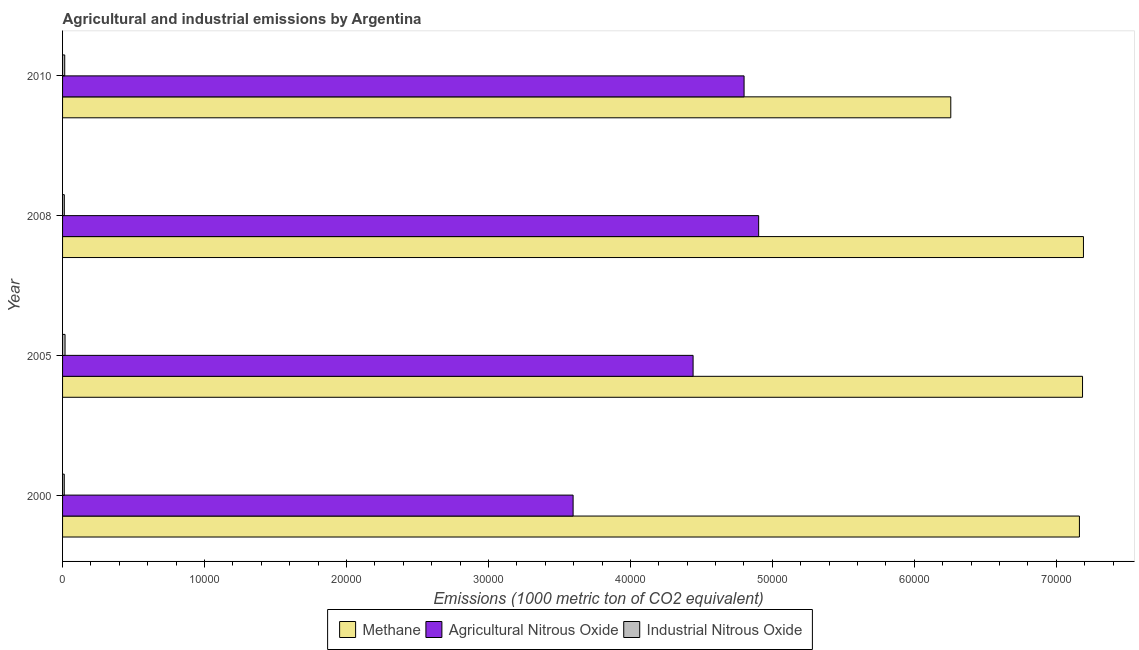How many different coloured bars are there?
Keep it short and to the point. 3. How many groups of bars are there?
Your answer should be compact. 4. Are the number of bars on each tick of the Y-axis equal?
Provide a succinct answer. Yes. How many bars are there on the 1st tick from the bottom?
Give a very brief answer. 3. What is the label of the 2nd group of bars from the top?
Provide a short and direct response. 2008. In how many cases, is the number of bars for a given year not equal to the number of legend labels?
Your response must be concise. 0. What is the amount of agricultural nitrous oxide emissions in 2005?
Make the answer very short. 4.44e+04. Across all years, what is the maximum amount of methane emissions?
Provide a succinct answer. 7.19e+04. Across all years, what is the minimum amount of industrial nitrous oxide emissions?
Your response must be concise. 120. In which year was the amount of agricultural nitrous oxide emissions maximum?
Offer a very short reply. 2008. In which year was the amount of industrial nitrous oxide emissions minimum?
Your answer should be compact. 2000. What is the total amount of industrial nitrous oxide emissions in the graph?
Ensure brevity in your answer.  569.2. What is the difference between the amount of agricultural nitrous oxide emissions in 2000 and that in 2005?
Keep it short and to the point. -8453.1. What is the difference between the amount of agricultural nitrous oxide emissions in 2000 and the amount of industrial nitrous oxide emissions in 2005?
Keep it short and to the point. 3.58e+04. What is the average amount of industrial nitrous oxide emissions per year?
Your response must be concise. 142.3. In the year 2005, what is the difference between the amount of methane emissions and amount of industrial nitrous oxide emissions?
Offer a very short reply. 7.17e+04. In how many years, is the amount of industrial nitrous oxide emissions greater than 20000 metric ton?
Offer a terse response. 0. What is the ratio of the amount of industrial nitrous oxide emissions in 2000 to that in 2005?
Your answer should be very brief. 0.69. Is the amount of agricultural nitrous oxide emissions in 2008 less than that in 2010?
Your response must be concise. No. What is the difference between the highest and the second highest amount of methane emissions?
Your answer should be compact. 64.1. What is the difference between the highest and the lowest amount of agricultural nitrous oxide emissions?
Your response must be concise. 1.31e+04. Is the sum of the amount of agricultural nitrous oxide emissions in 2005 and 2010 greater than the maximum amount of industrial nitrous oxide emissions across all years?
Offer a very short reply. Yes. What does the 3rd bar from the top in 2005 represents?
Make the answer very short. Methane. What does the 2nd bar from the bottom in 2000 represents?
Your answer should be compact. Agricultural Nitrous Oxide. Is it the case that in every year, the sum of the amount of methane emissions and amount of agricultural nitrous oxide emissions is greater than the amount of industrial nitrous oxide emissions?
Offer a terse response. Yes. How many bars are there?
Make the answer very short. 12. Are all the bars in the graph horizontal?
Provide a short and direct response. Yes. What is the difference between two consecutive major ticks on the X-axis?
Keep it short and to the point. 10000. Does the graph contain any zero values?
Keep it short and to the point. No. How are the legend labels stacked?
Your answer should be very brief. Horizontal. What is the title of the graph?
Make the answer very short. Agricultural and industrial emissions by Argentina. What is the label or title of the X-axis?
Make the answer very short. Emissions (1000 metric ton of CO2 equivalent). What is the label or title of the Y-axis?
Provide a succinct answer. Year. What is the Emissions (1000 metric ton of CO2 equivalent) of Methane in 2000?
Give a very brief answer. 7.16e+04. What is the Emissions (1000 metric ton of CO2 equivalent) of Agricultural Nitrous Oxide in 2000?
Your answer should be very brief. 3.60e+04. What is the Emissions (1000 metric ton of CO2 equivalent) of Industrial Nitrous Oxide in 2000?
Provide a short and direct response. 120. What is the Emissions (1000 metric ton of CO2 equivalent) in Methane in 2005?
Provide a succinct answer. 7.19e+04. What is the Emissions (1000 metric ton of CO2 equivalent) in Agricultural Nitrous Oxide in 2005?
Ensure brevity in your answer.  4.44e+04. What is the Emissions (1000 metric ton of CO2 equivalent) of Industrial Nitrous Oxide in 2005?
Make the answer very short. 174.4. What is the Emissions (1000 metric ton of CO2 equivalent) of Methane in 2008?
Provide a succinct answer. 7.19e+04. What is the Emissions (1000 metric ton of CO2 equivalent) of Agricultural Nitrous Oxide in 2008?
Provide a short and direct response. 4.90e+04. What is the Emissions (1000 metric ton of CO2 equivalent) in Industrial Nitrous Oxide in 2008?
Offer a terse response. 123. What is the Emissions (1000 metric ton of CO2 equivalent) in Methane in 2010?
Offer a terse response. 6.26e+04. What is the Emissions (1000 metric ton of CO2 equivalent) in Agricultural Nitrous Oxide in 2010?
Provide a short and direct response. 4.80e+04. What is the Emissions (1000 metric ton of CO2 equivalent) of Industrial Nitrous Oxide in 2010?
Offer a very short reply. 151.8. Across all years, what is the maximum Emissions (1000 metric ton of CO2 equivalent) of Methane?
Offer a terse response. 7.19e+04. Across all years, what is the maximum Emissions (1000 metric ton of CO2 equivalent) in Agricultural Nitrous Oxide?
Provide a succinct answer. 4.90e+04. Across all years, what is the maximum Emissions (1000 metric ton of CO2 equivalent) of Industrial Nitrous Oxide?
Your answer should be very brief. 174.4. Across all years, what is the minimum Emissions (1000 metric ton of CO2 equivalent) in Methane?
Offer a very short reply. 6.26e+04. Across all years, what is the minimum Emissions (1000 metric ton of CO2 equivalent) of Agricultural Nitrous Oxide?
Offer a very short reply. 3.60e+04. Across all years, what is the minimum Emissions (1000 metric ton of CO2 equivalent) in Industrial Nitrous Oxide?
Make the answer very short. 120. What is the total Emissions (1000 metric ton of CO2 equivalent) in Methane in the graph?
Your response must be concise. 2.78e+05. What is the total Emissions (1000 metric ton of CO2 equivalent) of Agricultural Nitrous Oxide in the graph?
Your answer should be compact. 1.77e+05. What is the total Emissions (1000 metric ton of CO2 equivalent) in Industrial Nitrous Oxide in the graph?
Make the answer very short. 569.2. What is the difference between the Emissions (1000 metric ton of CO2 equivalent) of Methane in 2000 and that in 2005?
Offer a very short reply. -219. What is the difference between the Emissions (1000 metric ton of CO2 equivalent) in Agricultural Nitrous Oxide in 2000 and that in 2005?
Your response must be concise. -8453.1. What is the difference between the Emissions (1000 metric ton of CO2 equivalent) in Industrial Nitrous Oxide in 2000 and that in 2005?
Keep it short and to the point. -54.4. What is the difference between the Emissions (1000 metric ton of CO2 equivalent) of Methane in 2000 and that in 2008?
Provide a short and direct response. -283.1. What is the difference between the Emissions (1000 metric ton of CO2 equivalent) of Agricultural Nitrous Oxide in 2000 and that in 2008?
Keep it short and to the point. -1.31e+04. What is the difference between the Emissions (1000 metric ton of CO2 equivalent) of Industrial Nitrous Oxide in 2000 and that in 2008?
Give a very brief answer. -3. What is the difference between the Emissions (1000 metric ton of CO2 equivalent) in Methane in 2000 and that in 2010?
Provide a succinct answer. 9062.7. What is the difference between the Emissions (1000 metric ton of CO2 equivalent) in Agricultural Nitrous Oxide in 2000 and that in 2010?
Ensure brevity in your answer.  -1.20e+04. What is the difference between the Emissions (1000 metric ton of CO2 equivalent) of Industrial Nitrous Oxide in 2000 and that in 2010?
Offer a very short reply. -31.8. What is the difference between the Emissions (1000 metric ton of CO2 equivalent) in Methane in 2005 and that in 2008?
Provide a short and direct response. -64.1. What is the difference between the Emissions (1000 metric ton of CO2 equivalent) in Agricultural Nitrous Oxide in 2005 and that in 2008?
Your answer should be compact. -4617.7. What is the difference between the Emissions (1000 metric ton of CO2 equivalent) of Industrial Nitrous Oxide in 2005 and that in 2008?
Your answer should be very brief. 51.4. What is the difference between the Emissions (1000 metric ton of CO2 equivalent) of Methane in 2005 and that in 2010?
Give a very brief answer. 9281.7. What is the difference between the Emissions (1000 metric ton of CO2 equivalent) of Agricultural Nitrous Oxide in 2005 and that in 2010?
Your answer should be very brief. -3591.7. What is the difference between the Emissions (1000 metric ton of CO2 equivalent) in Industrial Nitrous Oxide in 2005 and that in 2010?
Offer a terse response. 22.6. What is the difference between the Emissions (1000 metric ton of CO2 equivalent) of Methane in 2008 and that in 2010?
Provide a succinct answer. 9345.8. What is the difference between the Emissions (1000 metric ton of CO2 equivalent) of Agricultural Nitrous Oxide in 2008 and that in 2010?
Your answer should be very brief. 1026. What is the difference between the Emissions (1000 metric ton of CO2 equivalent) of Industrial Nitrous Oxide in 2008 and that in 2010?
Keep it short and to the point. -28.8. What is the difference between the Emissions (1000 metric ton of CO2 equivalent) in Methane in 2000 and the Emissions (1000 metric ton of CO2 equivalent) in Agricultural Nitrous Oxide in 2005?
Your answer should be compact. 2.72e+04. What is the difference between the Emissions (1000 metric ton of CO2 equivalent) of Methane in 2000 and the Emissions (1000 metric ton of CO2 equivalent) of Industrial Nitrous Oxide in 2005?
Give a very brief answer. 7.15e+04. What is the difference between the Emissions (1000 metric ton of CO2 equivalent) in Agricultural Nitrous Oxide in 2000 and the Emissions (1000 metric ton of CO2 equivalent) in Industrial Nitrous Oxide in 2005?
Provide a succinct answer. 3.58e+04. What is the difference between the Emissions (1000 metric ton of CO2 equivalent) of Methane in 2000 and the Emissions (1000 metric ton of CO2 equivalent) of Agricultural Nitrous Oxide in 2008?
Ensure brevity in your answer.  2.26e+04. What is the difference between the Emissions (1000 metric ton of CO2 equivalent) of Methane in 2000 and the Emissions (1000 metric ton of CO2 equivalent) of Industrial Nitrous Oxide in 2008?
Give a very brief answer. 7.15e+04. What is the difference between the Emissions (1000 metric ton of CO2 equivalent) in Agricultural Nitrous Oxide in 2000 and the Emissions (1000 metric ton of CO2 equivalent) in Industrial Nitrous Oxide in 2008?
Your answer should be compact. 3.58e+04. What is the difference between the Emissions (1000 metric ton of CO2 equivalent) of Methane in 2000 and the Emissions (1000 metric ton of CO2 equivalent) of Agricultural Nitrous Oxide in 2010?
Keep it short and to the point. 2.36e+04. What is the difference between the Emissions (1000 metric ton of CO2 equivalent) in Methane in 2000 and the Emissions (1000 metric ton of CO2 equivalent) in Industrial Nitrous Oxide in 2010?
Provide a succinct answer. 7.15e+04. What is the difference between the Emissions (1000 metric ton of CO2 equivalent) of Agricultural Nitrous Oxide in 2000 and the Emissions (1000 metric ton of CO2 equivalent) of Industrial Nitrous Oxide in 2010?
Provide a short and direct response. 3.58e+04. What is the difference between the Emissions (1000 metric ton of CO2 equivalent) of Methane in 2005 and the Emissions (1000 metric ton of CO2 equivalent) of Agricultural Nitrous Oxide in 2008?
Give a very brief answer. 2.28e+04. What is the difference between the Emissions (1000 metric ton of CO2 equivalent) of Methane in 2005 and the Emissions (1000 metric ton of CO2 equivalent) of Industrial Nitrous Oxide in 2008?
Ensure brevity in your answer.  7.17e+04. What is the difference between the Emissions (1000 metric ton of CO2 equivalent) in Agricultural Nitrous Oxide in 2005 and the Emissions (1000 metric ton of CO2 equivalent) in Industrial Nitrous Oxide in 2008?
Provide a succinct answer. 4.43e+04. What is the difference between the Emissions (1000 metric ton of CO2 equivalent) of Methane in 2005 and the Emissions (1000 metric ton of CO2 equivalent) of Agricultural Nitrous Oxide in 2010?
Your answer should be compact. 2.38e+04. What is the difference between the Emissions (1000 metric ton of CO2 equivalent) in Methane in 2005 and the Emissions (1000 metric ton of CO2 equivalent) in Industrial Nitrous Oxide in 2010?
Ensure brevity in your answer.  7.17e+04. What is the difference between the Emissions (1000 metric ton of CO2 equivalent) of Agricultural Nitrous Oxide in 2005 and the Emissions (1000 metric ton of CO2 equivalent) of Industrial Nitrous Oxide in 2010?
Offer a very short reply. 4.43e+04. What is the difference between the Emissions (1000 metric ton of CO2 equivalent) in Methane in 2008 and the Emissions (1000 metric ton of CO2 equivalent) in Agricultural Nitrous Oxide in 2010?
Your answer should be compact. 2.39e+04. What is the difference between the Emissions (1000 metric ton of CO2 equivalent) of Methane in 2008 and the Emissions (1000 metric ton of CO2 equivalent) of Industrial Nitrous Oxide in 2010?
Ensure brevity in your answer.  7.18e+04. What is the difference between the Emissions (1000 metric ton of CO2 equivalent) of Agricultural Nitrous Oxide in 2008 and the Emissions (1000 metric ton of CO2 equivalent) of Industrial Nitrous Oxide in 2010?
Offer a terse response. 4.89e+04. What is the average Emissions (1000 metric ton of CO2 equivalent) in Methane per year?
Make the answer very short. 6.95e+04. What is the average Emissions (1000 metric ton of CO2 equivalent) in Agricultural Nitrous Oxide per year?
Your response must be concise. 4.44e+04. What is the average Emissions (1000 metric ton of CO2 equivalent) of Industrial Nitrous Oxide per year?
Offer a terse response. 142.3. In the year 2000, what is the difference between the Emissions (1000 metric ton of CO2 equivalent) of Methane and Emissions (1000 metric ton of CO2 equivalent) of Agricultural Nitrous Oxide?
Offer a very short reply. 3.57e+04. In the year 2000, what is the difference between the Emissions (1000 metric ton of CO2 equivalent) in Methane and Emissions (1000 metric ton of CO2 equivalent) in Industrial Nitrous Oxide?
Offer a terse response. 7.15e+04. In the year 2000, what is the difference between the Emissions (1000 metric ton of CO2 equivalent) of Agricultural Nitrous Oxide and Emissions (1000 metric ton of CO2 equivalent) of Industrial Nitrous Oxide?
Keep it short and to the point. 3.58e+04. In the year 2005, what is the difference between the Emissions (1000 metric ton of CO2 equivalent) of Methane and Emissions (1000 metric ton of CO2 equivalent) of Agricultural Nitrous Oxide?
Your response must be concise. 2.74e+04. In the year 2005, what is the difference between the Emissions (1000 metric ton of CO2 equivalent) of Methane and Emissions (1000 metric ton of CO2 equivalent) of Industrial Nitrous Oxide?
Give a very brief answer. 7.17e+04. In the year 2005, what is the difference between the Emissions (1000 metric ton of CO2 equivalent) of Agricultural Nitrous Oxide and Emissions (1000 metric ton of CO2 equivalent) of Industrial Nitrous Oxide?
Offer a terse response. 4.42e+04. In the year 2008, what is the difference between the Emissions (1000 metric ton of CO2 equivalent) of Methane and Emissions (1000 metric ton of CO2 equivalent) of Agricultural Nitrous Oxide?
Provide a short and direct response. 2.29e+04. In the year 2008, what is the difference between the Emissions (1000 metric ton of CO2 equivalent) in Methane and Emissions (1000 metric ton of CO2 equivalent) in Industrial Nitrous Oxide?
Keep it short and to the point. 7.18e+04. In the year 2008, what is the difference between the Emissions (1000 metric ton of CO2 equivalent) in Agricultural Nitrous Oxide and Emissions (1000 metric ton of CO2 equivalent) in Industrial Nitrous Oxide?
Keep it short and to the point. 4.89e+04. In the year 2010, what is the difference between the Emissions (1000 metric ton of CO2 equivalent) in Methane and Emissions (1000 metric ton of CO2 equivalent) in Agricultural Nitrous Oxide?
Your response must be concise. 1.46e+04. In the year 2010, what is the difference between the Emissions (1000 metric ton of CO2 equivalent) in Methane and Emissions (1000 metric ton of CO2 equivalent) in Industrial Nitrous Oxide?
Provide a short and direct response. 6.24e+04. In the year 2010, what is the difference between the Emissions (1000 metric ton of CO2 equivalent) of Agricultural Nitrous Oxide and Emissions (1000 metric ton of CO2 equivalent) of Industrial Nitrous Oxide?
Ensure brevity in your answer.  4.79e+04. What is the ratio of the Emissions (1000 metric ton of CO2 equivalent) in Agricultural Nitrous Oxide in 2000 to that in 2005?
Give a very brief answer. 0.81. What is the ratio of the Emissions (1000 metric ton of CO2 equivalent) of Industrial Nitrous Oxide in 2000 to that in 2005?
Your response must be concise. 0.69. What is the ratio of the Emissions (1000 metric ton of CO2 equivalent) of Methane in 2000 to that in 2008?
Make the answer very short. 1. What is the ratio of the Emissions (1000 metric ton of CO2 equivalent) in Agricultural Nitrous Oxide in 2000 to that in 2008?
Offer a terse response. 0.73. What is the ratio of the Emissions (1000 metric ton of CO2 equivalent) of Industrial Nitrous Oxide in 2000 to that in 2008?
Keep it short and to the point. 0.98. What is the ratio of the Emissions (1000 metric ton of CO2 equivalent) of Methane in 2000 to that in 2010?
Provide a short and direct response. 1.14. What is the ratio of the Emissions (1000 metric ton of CO2 equivalent) in Agricultural Nitrous Oxide in 2000 to that in 2010?
Give a very brief answer. 0.75. What is the ratio of the Emissions (1000 metric ton of CO2 equivalent) in Industrial Nitrous Oxide in 2000 to that in 2010?
Your answer should be compact. 0.79. What is the ratio of the Emissions (1000 metric ton of CO2 equivalent) in Methane in 2005 to that in 2008?
Offer a terse response. 1. What is the ratio of the Emissions (1000 metric ton of CO2 equivalent) of Agricultural Nitrous Oxide in 2005 to that in 2008?
Make the answer very short. 0.91. What is the ratio of the Emissions (1000 metric ton of CO2 equivalent) in Industrial Nitrous Oxide in 2005 to that in 2008?
Keep it short and to the point. 1.42. What is the ratio of the Emissions (1000 metric ton of CO2 equivalent) in Methane in 2005 to that in 2010?
Make the answer very short. 1.15. What is the ratio of the Emissions (1000 metric ton of CO2 equivalent) in Agricultural Nitrous Oxide in 2005 to that in 2010?
Provide a succinct answer. 0.93. What is the ratio of the Emissions (1000 metric ton of CO2 equivalent) in Industrial Nitrous Oxide in 2005 to that in 2010?
Offer a very short reply. 1.15. What is the ratio of the Emissions (1000 metric ton of CO2 equivalent) in Methane in 2008 to that in 2010?
Give a very brief answer. 1.15. What is the ratio of the Emissions (1000 metric ton of CO2 equivalent) of Agricultural Nitrous Oxide in 2008 to that in 2010?
Give a very brief answer. 1.02. What is the ratio of the Emissions (1000 metric ton of CO2 equivalent) of Industrial Nitrous Oxide in 2008 to that in 2010?
Your answer should be compact. 0.81. What is the difference between the highest and the second highest Emissions (1000 metric ton of CO2 equivalent) of Methane?
Ensure brevity in your answer.  64.1. What is the difference between the highest and the second highest Emissions (1000 metric ton of CO2 equivalent) of Agricultural Nitrous Oxide?
Ensure brevity in your answer.  1026. What is the difference between the highest and the second highest Emissions (1000 metric ton of CO2 equivalent) of Industrial Nitrous Oxide?
Your response must be concise. 22.6. What is the difference between the highest and the lowest Emissions (1000 metric ton of CO2 equivalent) of Methane?
Provide a succinct answer. 9345.8. What is the difference between the highest and the lowest Emissions (1000 metric ton of CO2 equivalent) of Agricultural Nitrous Oxide?
Keep it short and to the point. 1.31e+04. What is the difference between the highest and the lowest Emissions (1000 metric ton of CO2 equivalent) of Industrial Nitrous Oxide?
Provide a short and direct response. 54.4. 